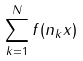<formula> <loc_0><loc_0><loc_500><loc_500>\sum _ { k = 1 } ^ { N } f ( n _ { k } x )</formula> 